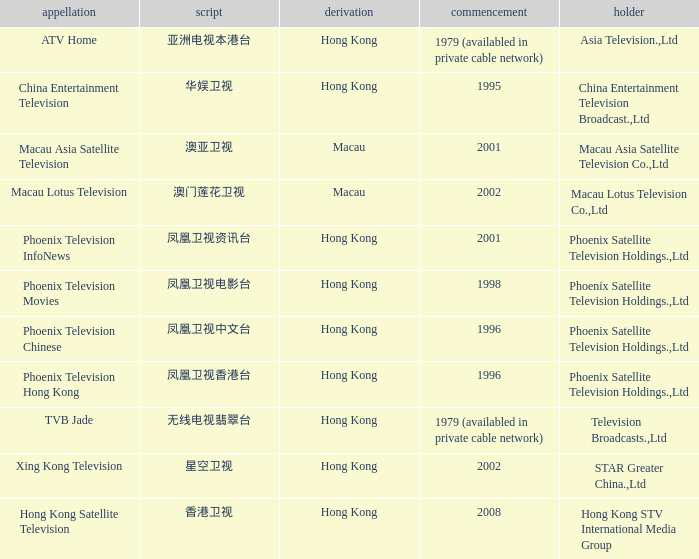What is the Hanzi of Hong Kong in 1998? 凤凰卫视电影台. 